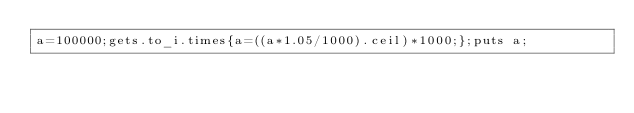<code> <loc_0><loc_0><loc_500><loc_500><_Ruby_>a=100000;gets.to_i.times{a=((a*1.05/1000).ceil)*1000;};puts a;</code> 